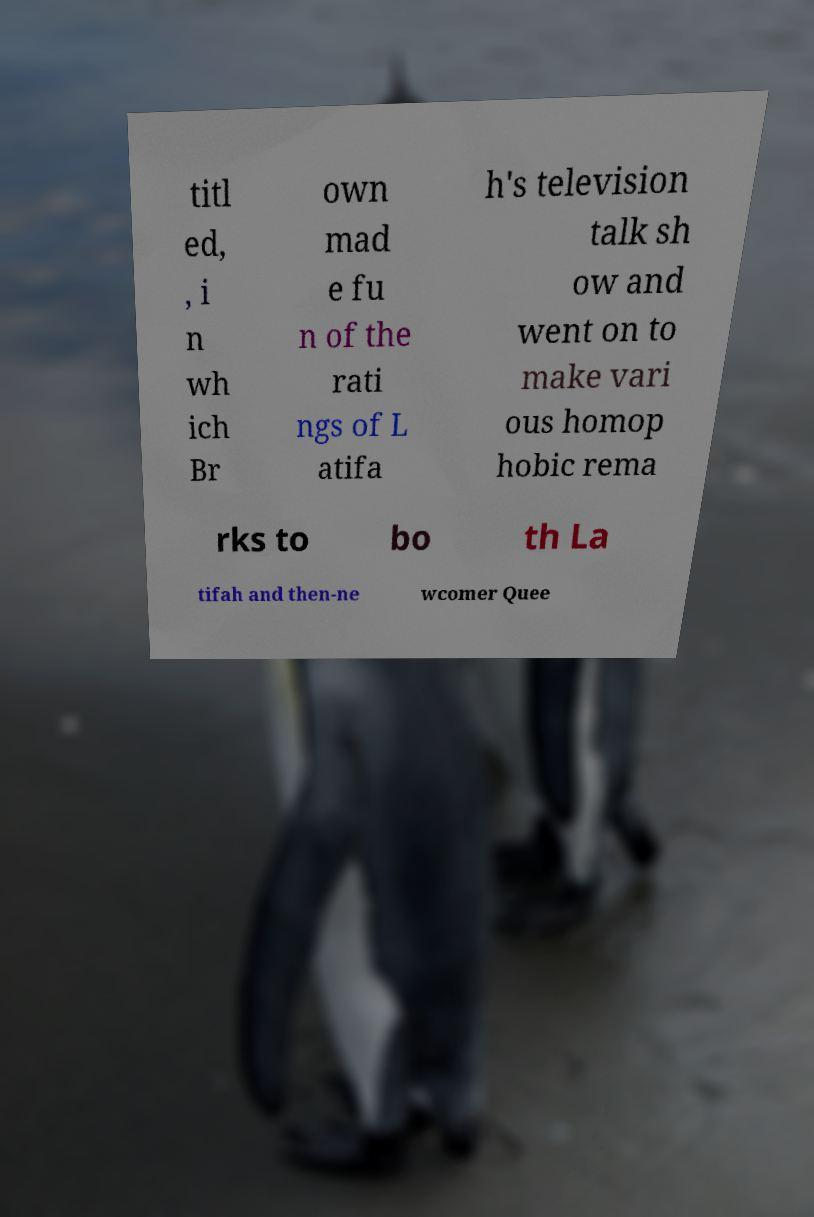What messages or text are displayed in this image? I need them in a readable, typed format. titl ed, , i n wh ich Br own mad e fu n of the rati ngs of L atifa h's television talk sh ow and went on to make vari ous homop hobic rema rks to bo th La tifah and then-ne wcomer Quee 